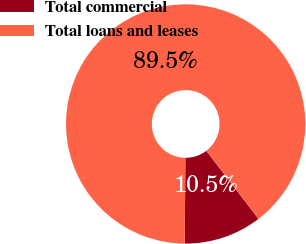<chart> <loc_0><loc_0><loc_500><loc_500><pie_chart><fcel>Total commercial<fcel>Total loans and leases<nl><fcel>10.54%<fcel>89.46%<nl></chart> 